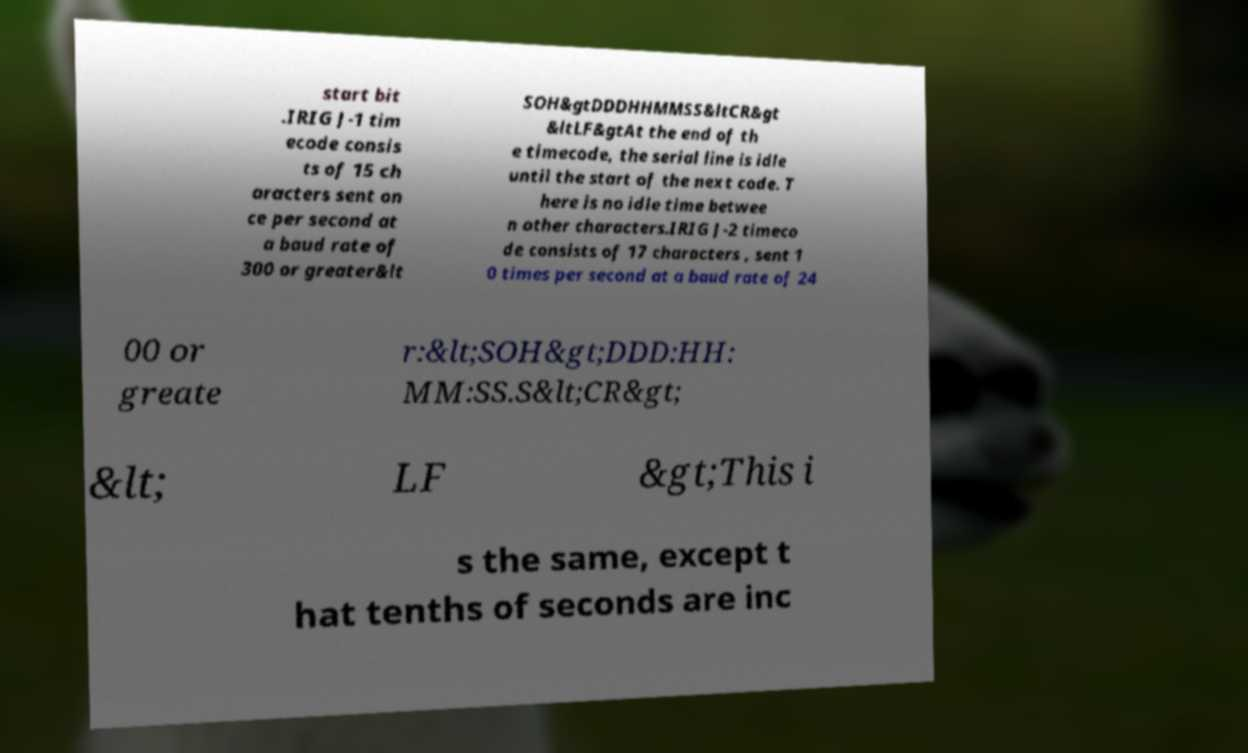What messages or text are displayed in this image? I need them in a readable, typed format. start bit .IRIG J-1 tim ecode consis ts of 15 ch aracters sent on ce per second at a baud rate of 300 or greater&lt SOH&gtDDDHHMMSS&ltCR&gt &ltLF&gtAt the end of th e timecode, the serial line is idle until the start of the next code. T here is no idle time betwee n other characters.IRIG J-2 timeco de consists of 17 characters , sent 1 0 times per second at a baud rate of 24 00 or greate r:&lt;SOH&gt;DDD:HH: MM:SS.S&lt;CR&gt; &lt; LF &gt;This i s the same, except t hat tenths of seconds are inc 